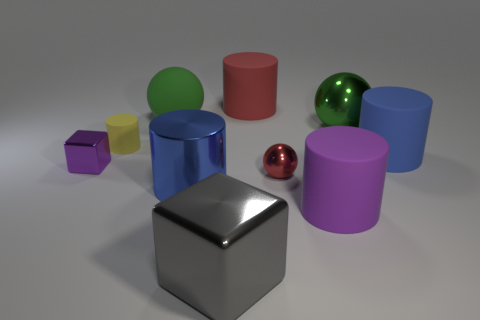Do the tiny rubber thing and the green metal object have the same shape?
Provide a short and direct response. No. How many other things are the same size as the yellow cylinder?
Offer a terse response. 2. How many objects are either spheres in front of the green shiny ball or tiny yellow things?
Provide a succinct answer. 2. What is the color of the small cylinder?
Make the answer very short. Yellow. There is a green sphere that is on the left side of the large green metallic sphere; what is it made of?
Your response must be concise. Rubber. There is a blue metal object; does it have the same shape as the green thing that is left of the purple cylinder?
Make the answer very short. No. Are there more green matte balls than matte objects?
Your response must be concise. No. Is there anything else that has the same color as the big metallic cube?
Provide a succinct answer. No. The green object that is the same material as the tiny purple object is what shape?
Ensure brevity in your answer.  Sphere. There is a purple object in front of the block that is behind the large purple matte object; what is its material?
Keep it short and to the point. Rubber. 